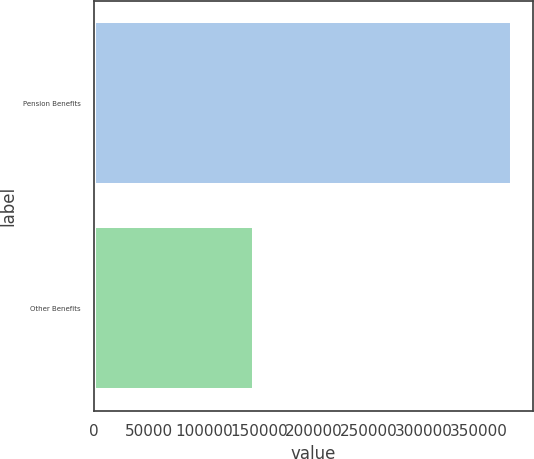<chart> <loc_0><loc_0><loc_500><loc_500><bar_chart><fcel>Pension Benefits<fcel>Other Benefits<nl><fcel>379793<fcel>145644<nl></chart> 